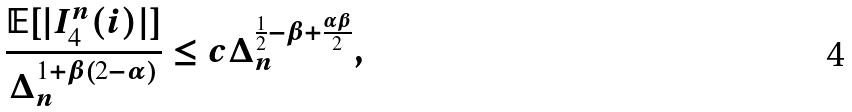<formula> <loc_0><loc_0><loc_500><loc_500>\frac { \mathbb { E } [ | I _ { 4 } ^ { n } ( i ) | ] } { \Delta _ { n } ^ { 1 + \beta ( 2 - \alpha ) } } \leq c \Delta _ { n } ^ { \frac { 1 } { 2 } - \beta + \frac { \alpha \beta } { 2 } } ,</formula> 